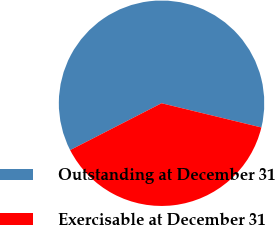Convert chart to OTSL. <chart><loc_0><loc_0><loc_500><loc_500><pie_chart><fcel>Outstanding at December 31<fcel>Exercisable at December 31<nl><fcel>61.33%<fcel>38.67%<nl></chart> 